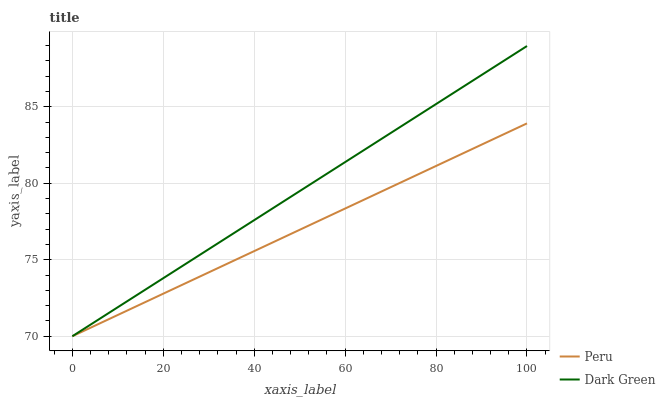Does Peru have the minimum area under the curve?
Answer yes or no. Yes. Does Dark Green have the maximum area under the curve?
Answer yes or no. Yes. Does Dark Green have the minimum area under the curve?
Answer yes or no. No. Is Dark Green the smoothest?
Answer yes or no. Yes. Is Peru the roughest?
Answer yes or no. Yes. Is Dark Green the roughest?
Answer yes or no. No. Does Peru have the lowest value?
Answer yes or no. Yes. Does Dark Green have the highest value?
Answer yes or no. Yes. Does Peru intersect Dark Green?
Answer yes or no. Yes. Is Peru less than Dark Green?
Answer yes or no. No. Is Peru greater than Dark Green?
Answer yes or no. No. 